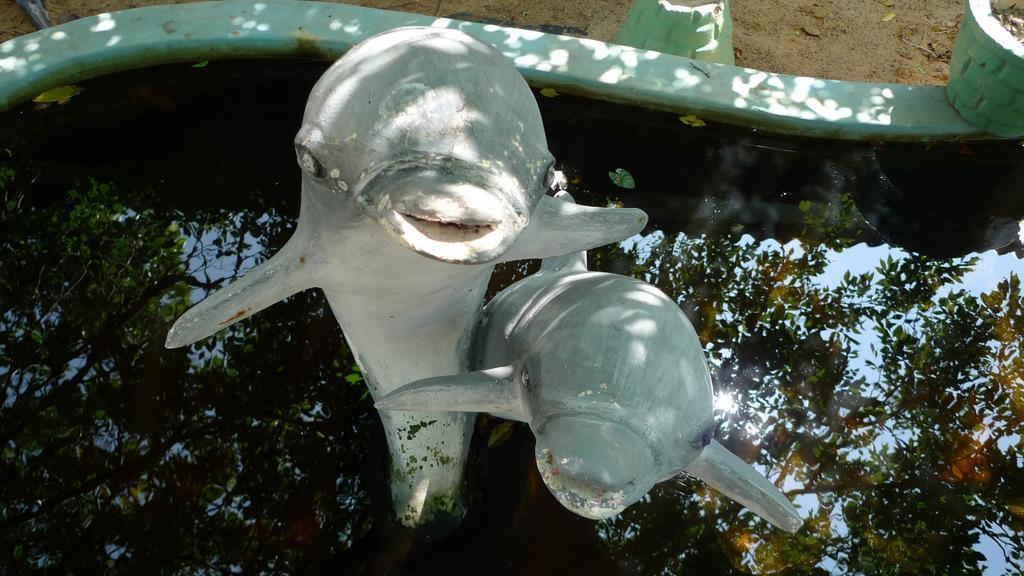Could you give a brief overview of what you see in this image? In this image at the center there is a depiction of dolphins and we can see the reflection of a tree. There is water in the pond. On the right side of the image there are flower pots. 